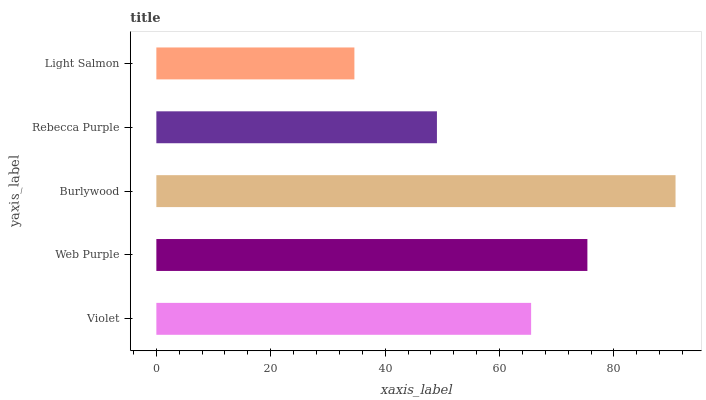Is Light Salmon the minimum?
Answer yes or no. Yes. Is Burlywood the maximum?
Answer yes or no. Yes. Is Web Purple the minimum?
Answer yes or no. No. Is Web Purple the maximum?
Answer yes or no. No. Is Web Purple greater than Violet?
Answer yes or no. Yes. Is Violet less than Web Purple?
Answer yes or no. Yes. Is Violet greater than Web Purple?
Answer yes or no. No. Is Web Purple less than Violet?
Answer yes or no. No. Is Violet the high median?
Answer yes or no. Yes. Is Violet the low median?
Answer yes or no. Yes. Is Burlywood the high median?
Answer yes or no. No. Is Light Salmon the low median?
Answer yes or no. No. 